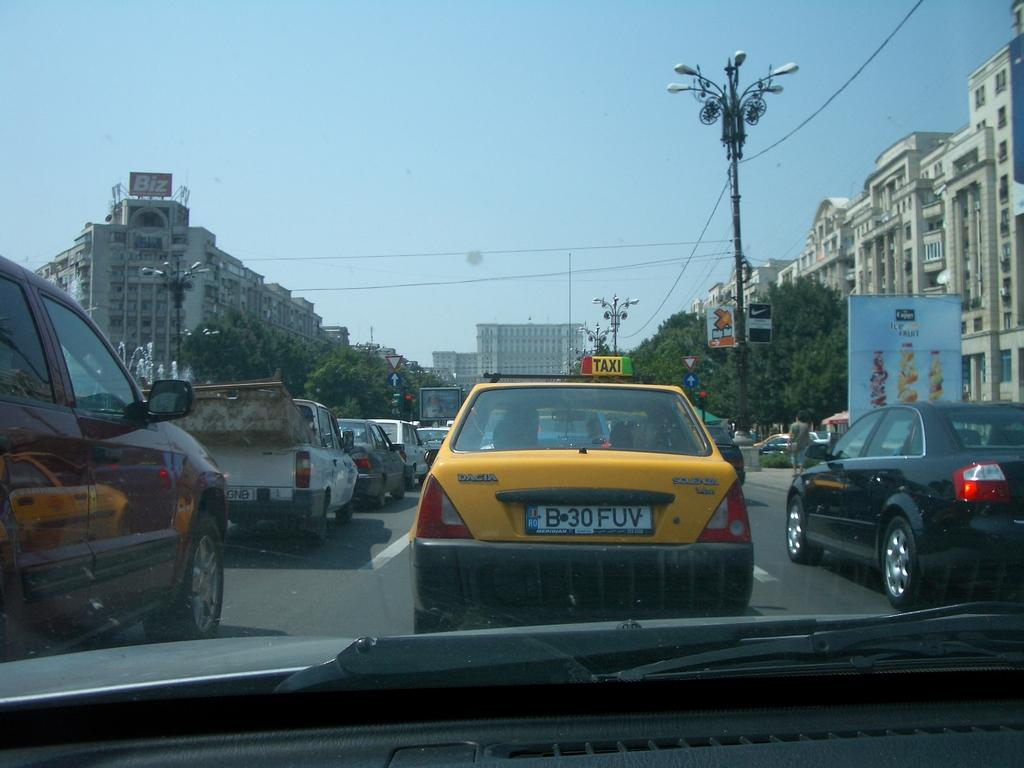What can be seen on the road in the image? There are vehicles on the road in the image. What type of vegetation is present on either side of the road? There are trees on either side of the road in the image. What type of structures are present on either side of the road? There are buildings on either side of the road in the image. Where is the mine located in the image? There is no mine present in the image. What type of cannon is visible in the image? There is no cannon present in the image. 